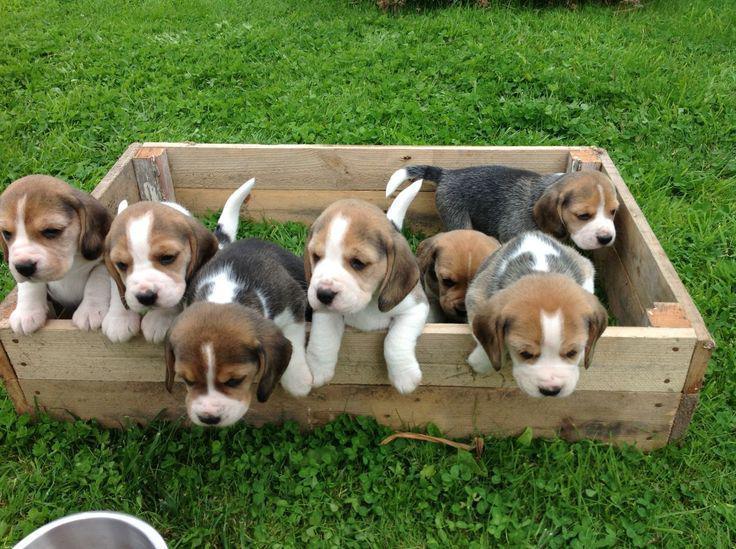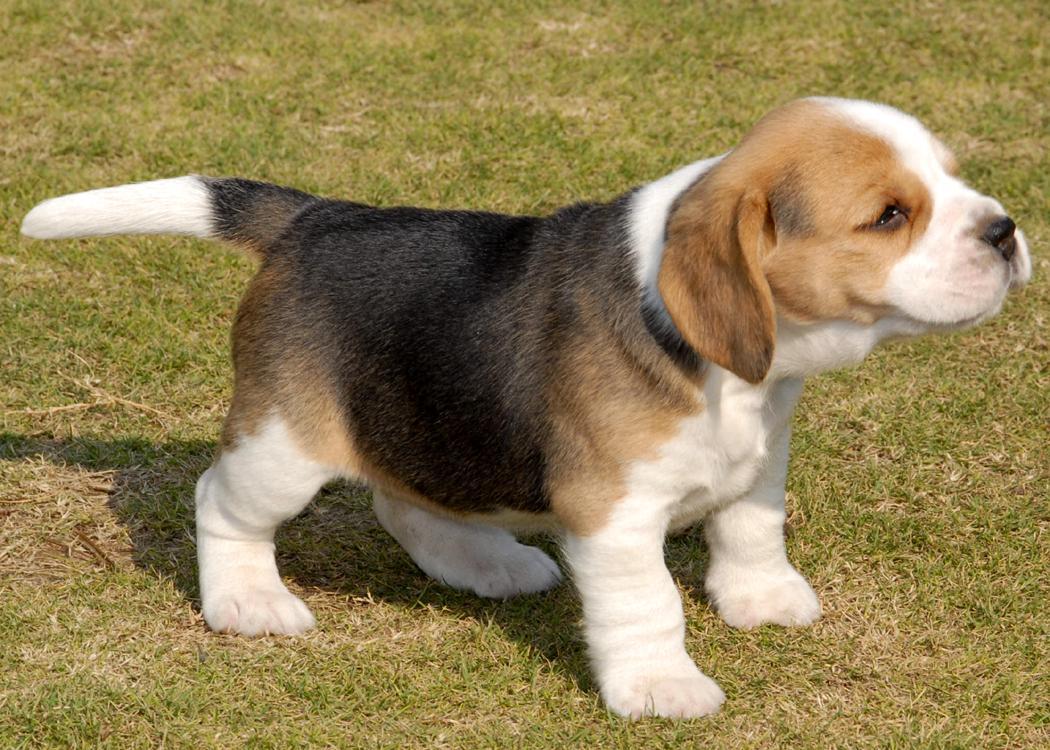The first image is the image on the left, the second image is the image on the right. For the images shown, is this caption "There are two dogs" true? Answer yes or no. No. 